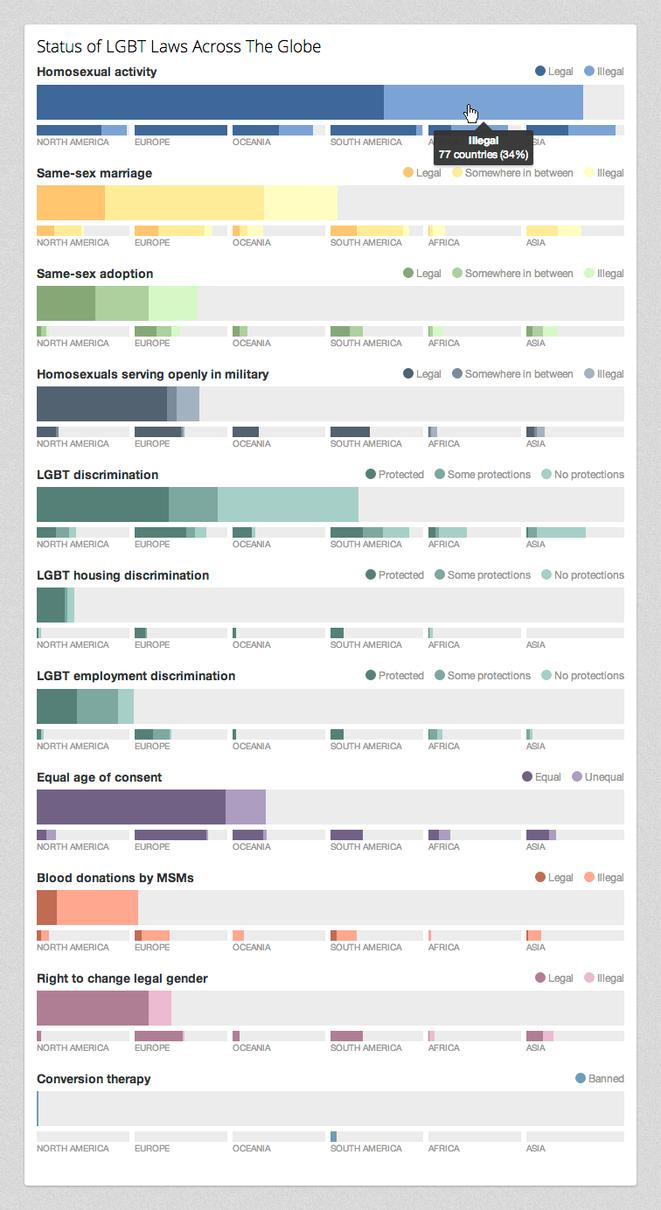List a handful of essential elements in this visual. According to recent reports, the highest rate of homosexuals serving in military can be found in Europe. According to the data, Europe has the highest percentage of protection against LGBT discrimination among all the continents. The legislation of banning conversion therapy is present in several countries of the continent of South America. 